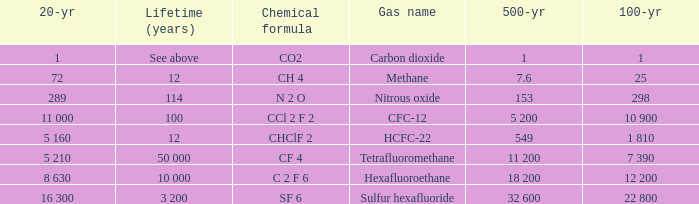What is the 20 year for Nitrous Oxide? 289.0. 